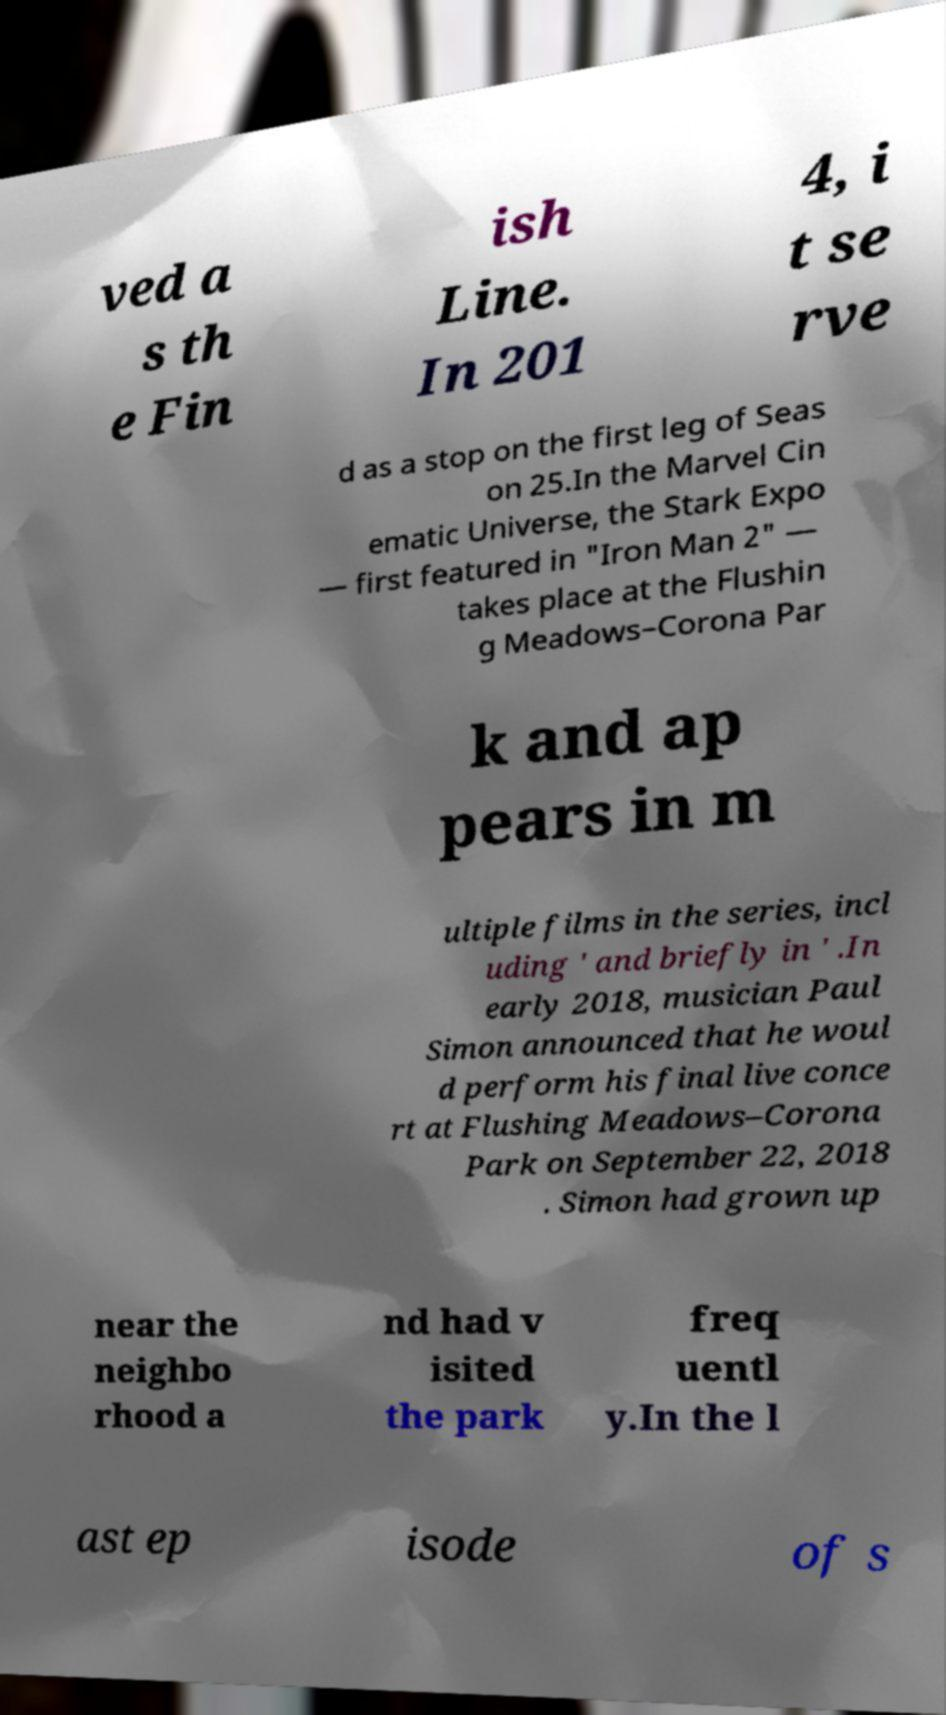There's text embedded in this image that I need extracted. Can you transcribe it verbatim? ved a s th e Fin ish Line. In 201 4, i t se rve d as a stop on the first leg of Seas on 25.In the Marvel Cin ematic Universe, the Stark Expo — first featured in "Iron Man 2" — takes place at the Flushin g Meadows–Corona Par k and ap pears in m ultiple films in the series, incl uding ' and briefly in ' .In early 2018, musician Paul Simon announced that he woul d perform his final live conce rt at Flushing Meadows–Corona Park on September 22, 2018 . Simon had grown up near the neighbo rhood a nd had v isited the park freq uentl y.In the l ast ep isode of s 